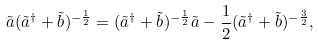<formula> <loc_0><loc_0><loc_500><loc_500>\tilde { a } ( \tilde { a } ^ { \dag } + \tilde { b } ) ^ { - \frac { 1 } { 2 } } = ( \tilde { a } ^ { \dag } + \tilde { b } ) ^ { - \frac { 1 } { 2 } } \tilde { a } - \frac { 1 } { 2 } ( \tilde { a } ^ { \dag } + \tilde { b } ) ^ { - \frac { 3 } { 2 } } ,</formula> 